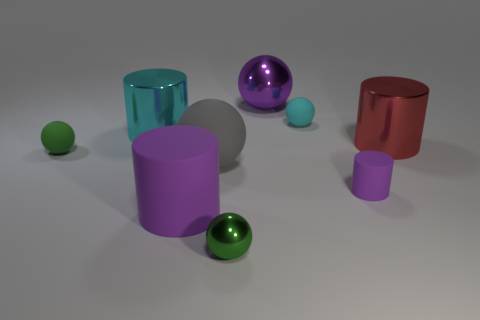Subtract all small green balls. How many balls are left? 3 Subtract 1 balls. How many balls are left? 4 Subtract 0 yellow spheres. How many objects are left? 9 Subtract all cylinders. How many objects are left? 5 Subtract all cyan cylinders. Subtract all gray blocks. How many cylinders are left? 3 Subtract all red cylinders. How many green spheres are left? 2 Subtract all large cyan metal objects. Subtract all tiny brown shiny balls. How many objects are left? 8 Add 6 big gray rubber spheres. How many big gray rubber spheres are left? 7 Add 4 green objects. How many green objects exist? 6 Add 1 large cyan cylinders. How many objects exist? 10 